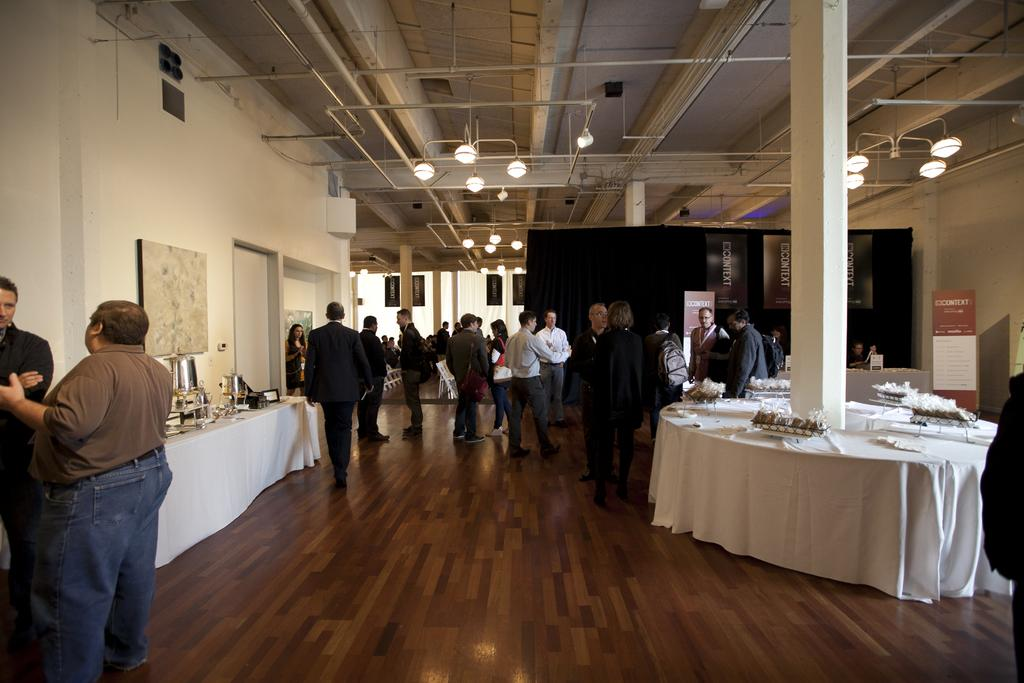What is happening in the image? There are people standing in the image. What can be seen in the background? There is a table in the image. What is on the table? Objects are present on the table. What architectural feature is visible in the image? There is a pillar in the image. How many lizards are crawling on the door in the image? There is no door or lizards present in the image. 